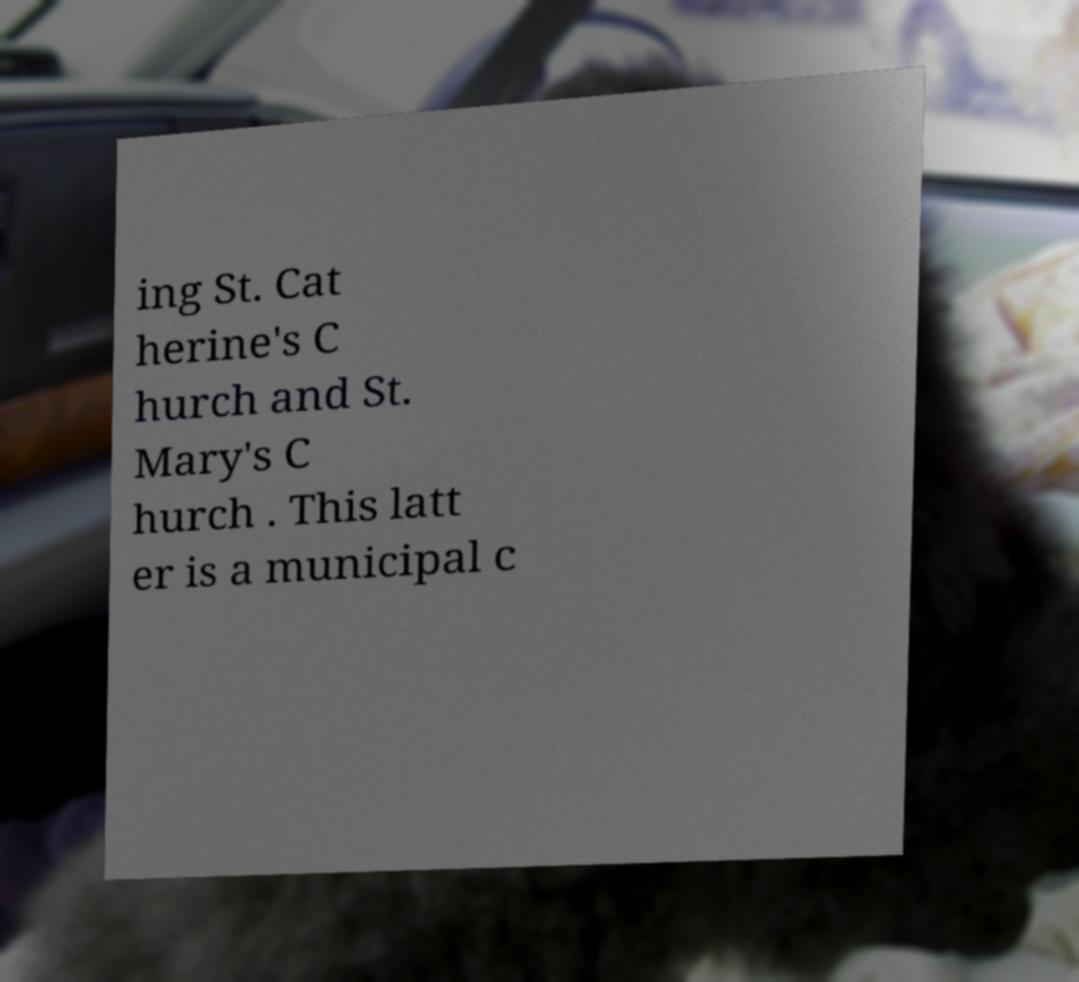Can you accurately transcribe the text from the provided image for me? ing St. Cat herine's C hurch and St. Mary's C hurch . This latt er is a municipal c 